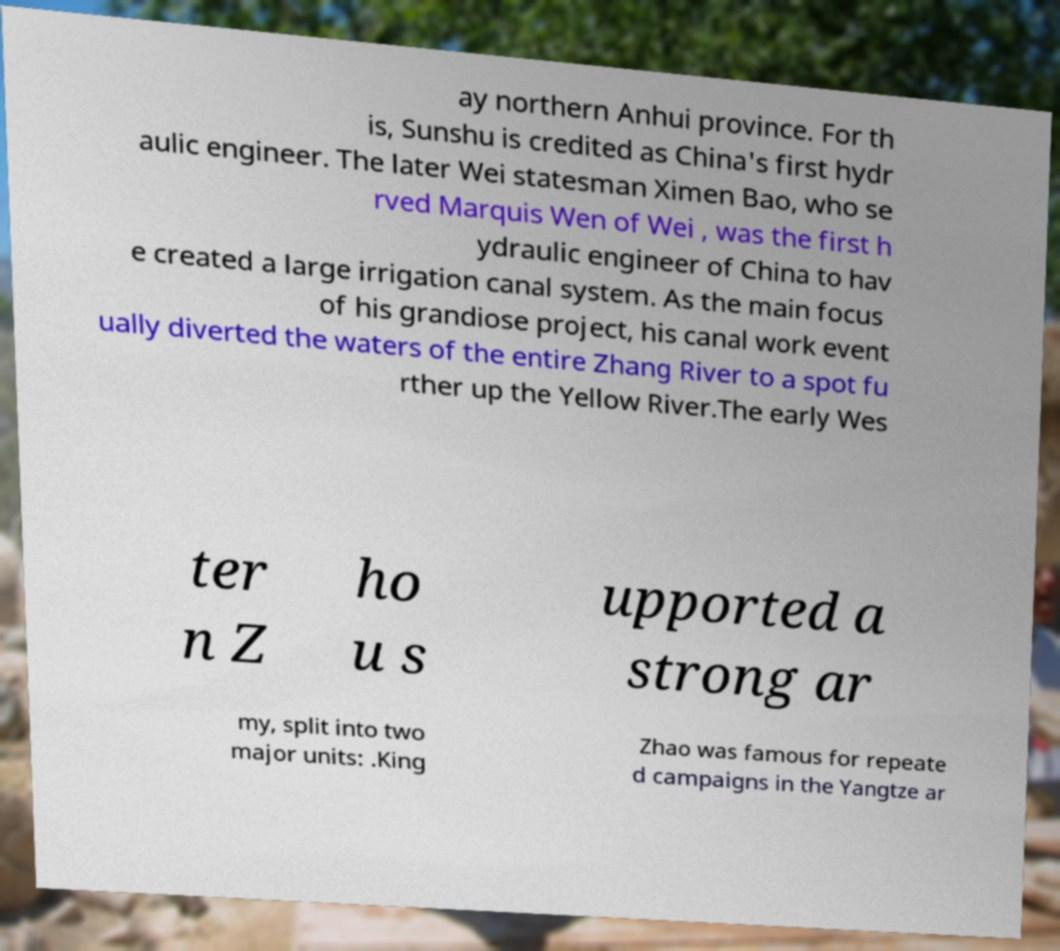Could you assist in decoding the text presented in this image and type it out clearly? ay northern Anhui province. For th is, Sunshu is credited as China's first hydr aulic engineer. The later Wei statesman Ximen Bao, who se rved Marquis Wen of Wei , was the first h ydraulic engineer of China to hav e created a large irrigation canal system. As the main focus of his grandiose project, his canal work event ually diverted the waters of the entire Zhang River to a spot fu rther up the Yellow River.The early Wes ter n Z ho u s upported a strong ar my, split into two major units: .King Zhao was famous for repeate d campaigns in the Yangtze ar 